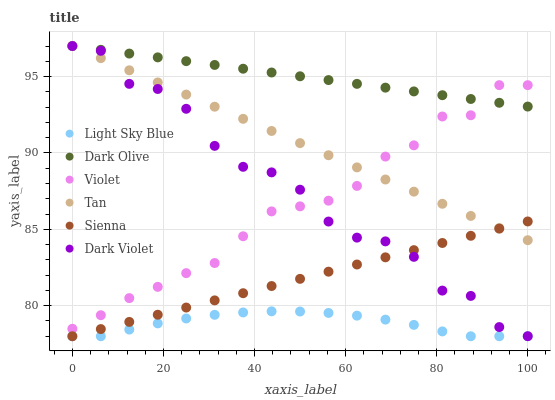Does Light Sky Blue have the minimum area under the curve?
Answer yes or no. Yes. Does Dark Olive have the maximum area under the curve?
Answer yes or no. Yes. Does Dark Violet have the minimum area under the curve?
Answer yes or no. No. Does Dark Violet have the maximum area under the curve?
Answer yes or no. No. Is Dark Olive the smoothest?
Answer yes or no. Yes. Is Dark Violet the roughest?
Answer yes or no. Yes. Is Sienna the smoothest?
Answer yes or no. No. Is Sienna the roughest?
Answer yes or no. No. Does Sienna have the lowest value?
Answer yes or no. Yes. Does Dark Violet have the lowest value?
Answer yes or no. No. Does Tan have the highest value?
Answer yes or no. Yes. Does Sienna have the highest value?
Answer yes or no. No. Is Sienna less than Violet?
Answer yes or no. Yes. Is Violet greater than Sienna?
Answer yes or no. Yes. Does Dark Violet intersect Sienna?
Answer yes or no. Yes. Is Dark Violet less than Sienna?
Answer yes or no. No. Is Dark Violet greater than Sienna?
Answer yes or no. No. Does Sienna intersect Violet?
Answer yes or no. No. 